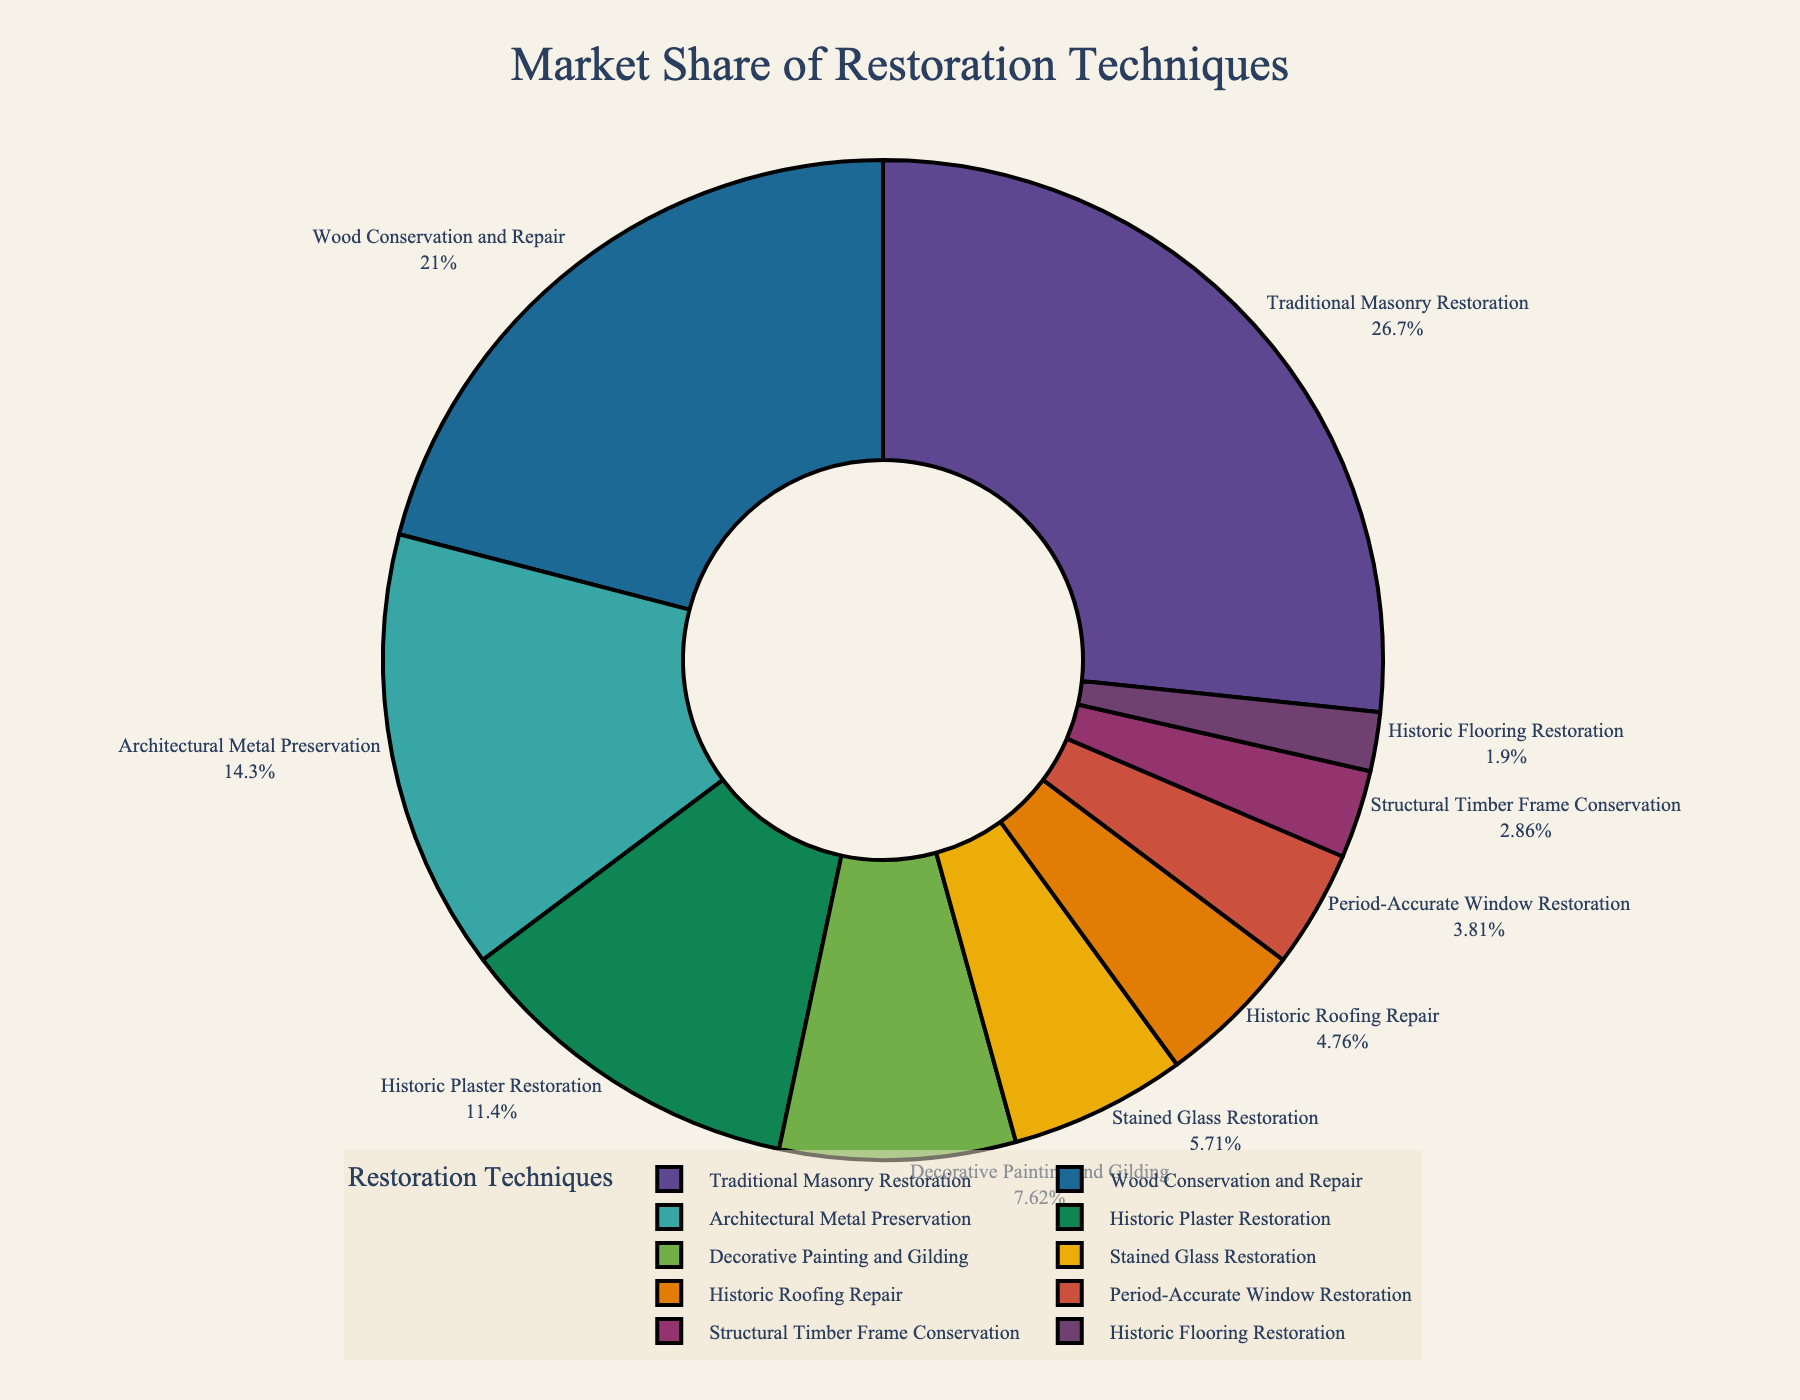What percentage of the market share is taken up by Traditional Masonry Restoration? To find the percentage of the market share for Traditional Masonry Restoration, locate the corresponding label in the pie chart and note the percentage indicated next to it.
Answer: 28% Which technique has the smallest market share? To determine the technique with the smallest market share, identify the segment in the pie chart with the smallest size. The label and percentage displayed for this segment indicate the technique and its market share.
Answer: Historic Flooring Restoration What is the combined market share of Wood Conservation and Repair and Architectural Metal Preservation? Locate the segments for Wood Conservation and Repair and Architectural Metal Preservation in the pie chart. Add their percentages together: 22% + 15% = 37%.
Answer: 37% How much larger is the market share of Historic Plaster Restoration compared to Historic Roofing Repair? Find the market shares for Historic Plaster Restoration and Historic Roofing Repair. Subtract the smaller percentage from the larger one: 12% - 5% = 7%.
Answer: 7% Which techniques have a market share greater than 10%? Identify the segments in the pie chart where the percentage is greater than 10%. The labels associated with these segments indicate the techniques.
Answer: Traditional Masonry Restoration, Wood Conservation and Repair, and Architectural Metal Preservation If the market share of Period-Accurate Window Restoration doubled, what would it be? Find the current market share for Period-Accurate Window Restoration: 4%. Double this percentage: 4% × 2 = 8%.
Answer: 8% Is the market share of Stained Glass Restoration greater or smaller than that of Decorative Painting and Gilding? Compare the market shares of Stained Glass Restoration and Decorative Painting and Gilding. Identify which percentage is larger: Stained Glass Restoration (6%) is smaller than Decorative Painting and Gilding (8%).
Answer: Smaller What is the total market share of all techniques with less than 6%? Identify the techniques with less than 6% market share from the pie chart. Add their percentages together: 5% + 4% + 3% + 2% = 14%.
Answer: 14% Which technique is represented by the largest segment in the pie chart? Locate the largest segment in the pie chart and check the label associated with it. The label indicates the technique.
Answer: Traditional Masonry Restoration 